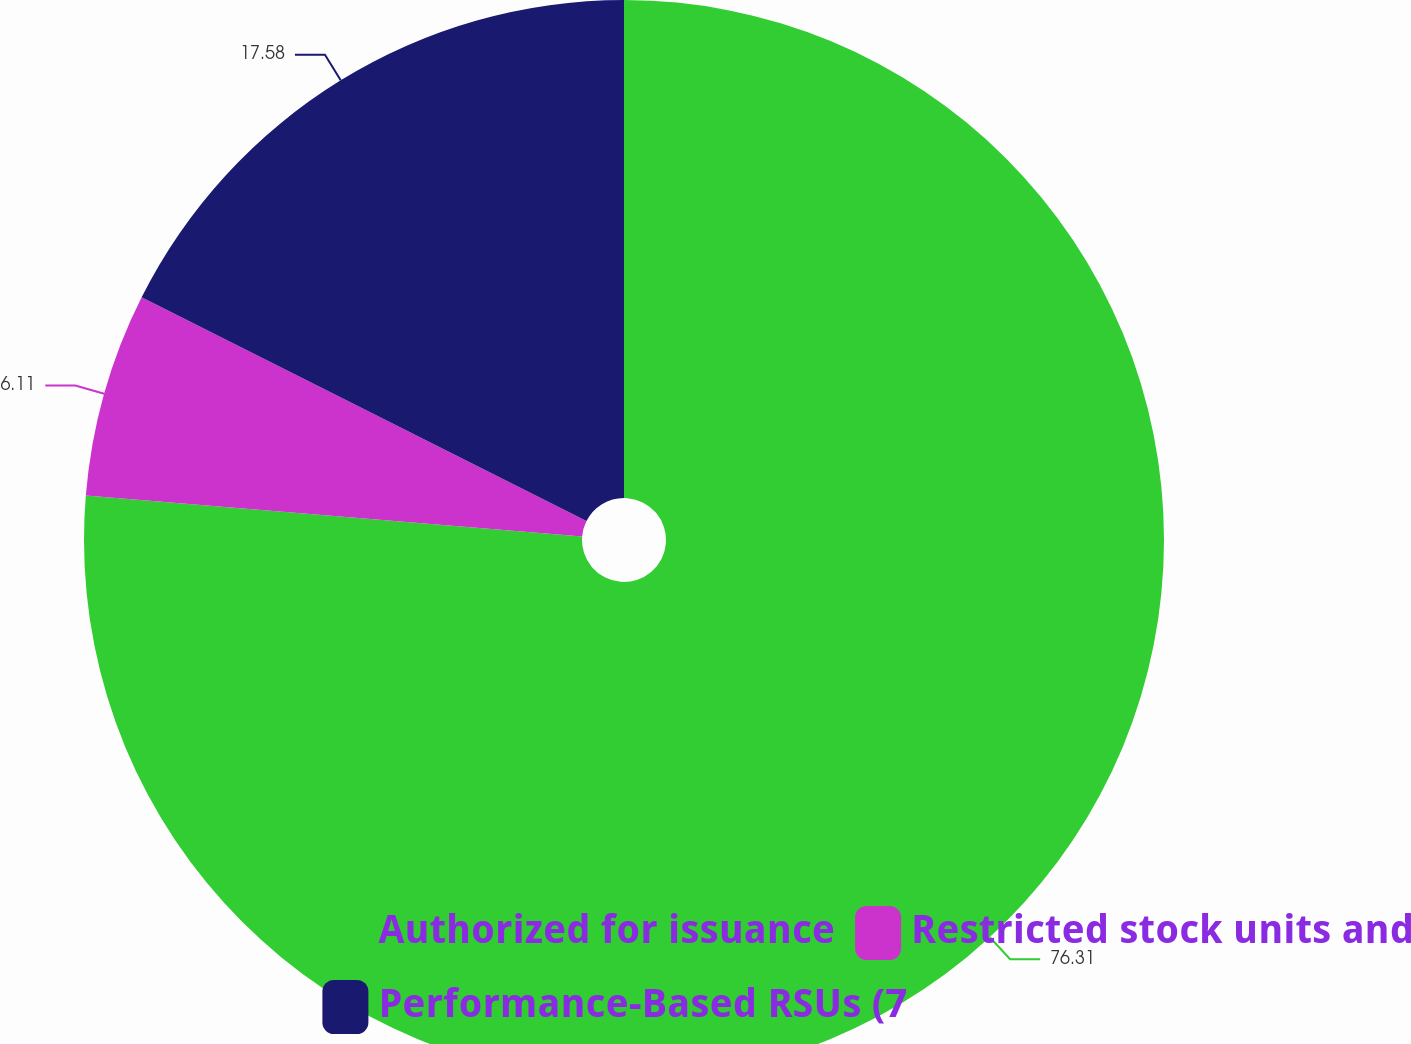Convert chart. <chart><loc_0><loc_0><loc_500><loc_500><pie_chart><fcel>Authorized for issuance<fcel>Restricted stock units and<fcel>Performance-Based RSUs (7<nl><fcel>76.31%<fcel>6.11%<fcel>17.58%<nl></chart> 